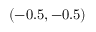Convert formula to latex. <formula><loc_0><loc_0><loc_500><loc_500>( - 0 . 5 , - 0 . 5 )</formula> 